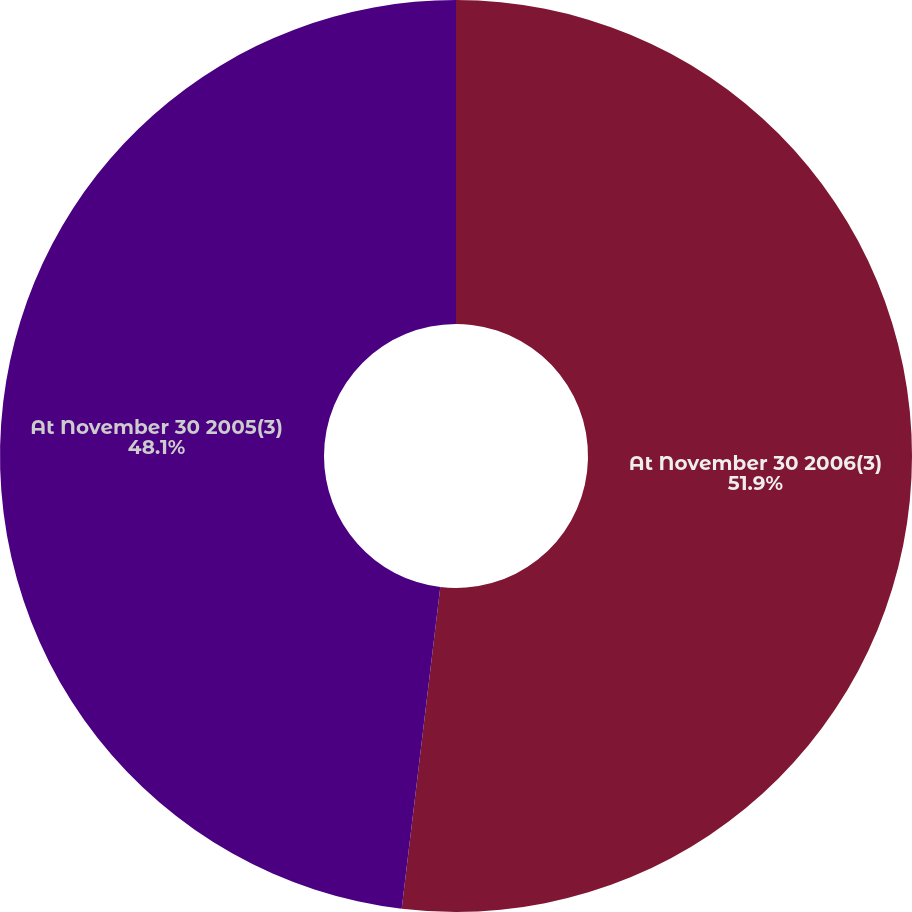Convert chart to OTSL. <chart><loc_0><loc_0><loc_500><loc_500><pie_chart><fcel>At November 30 2006(3)<fcel>At November 30 2005(3)<nl><fcel>51.9%<fcel>48.1%<nl></chart> 